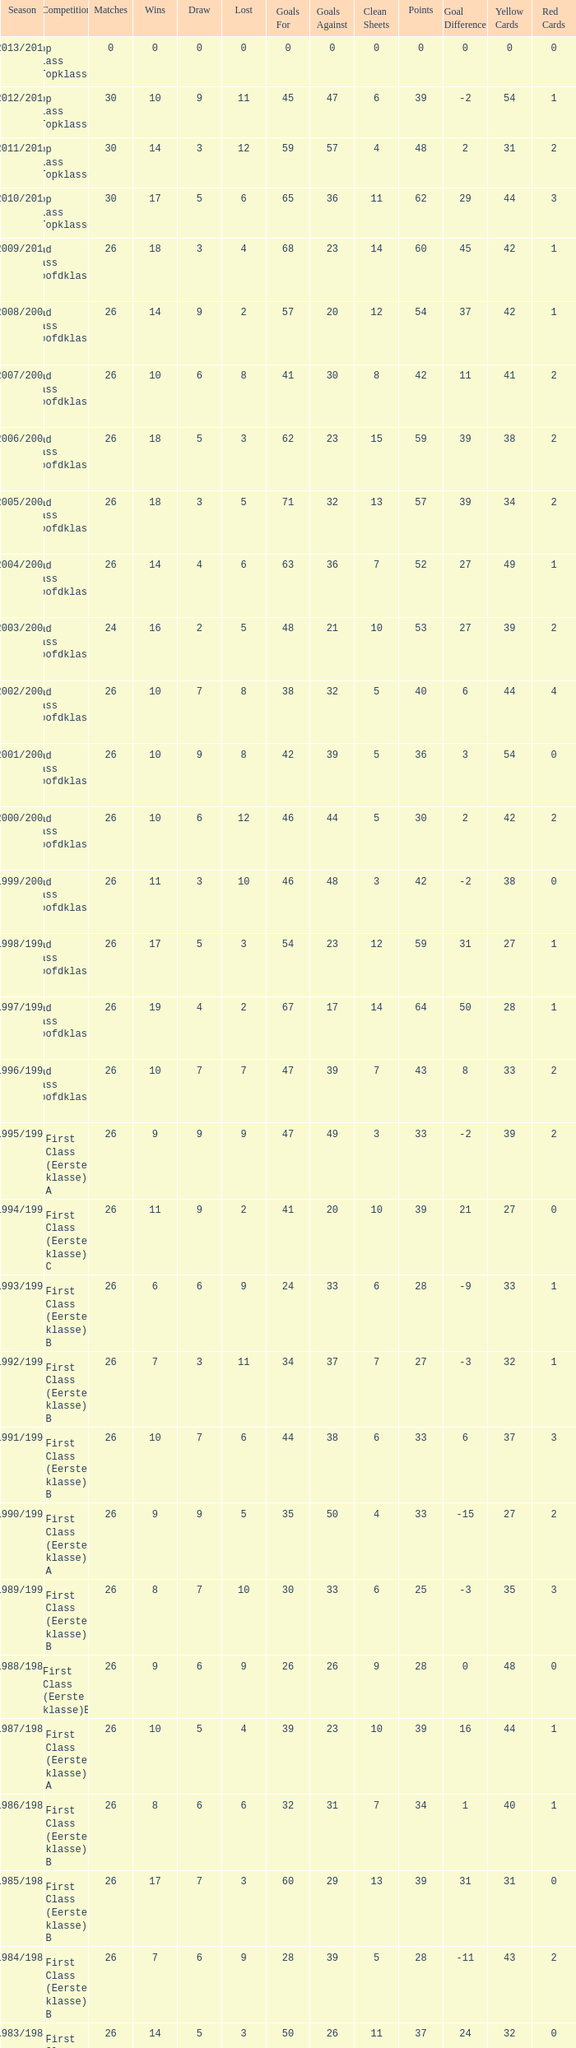What is the sum of the losses that a match score larger than 26, a points score of 62, and a draw greater than 5? None. 